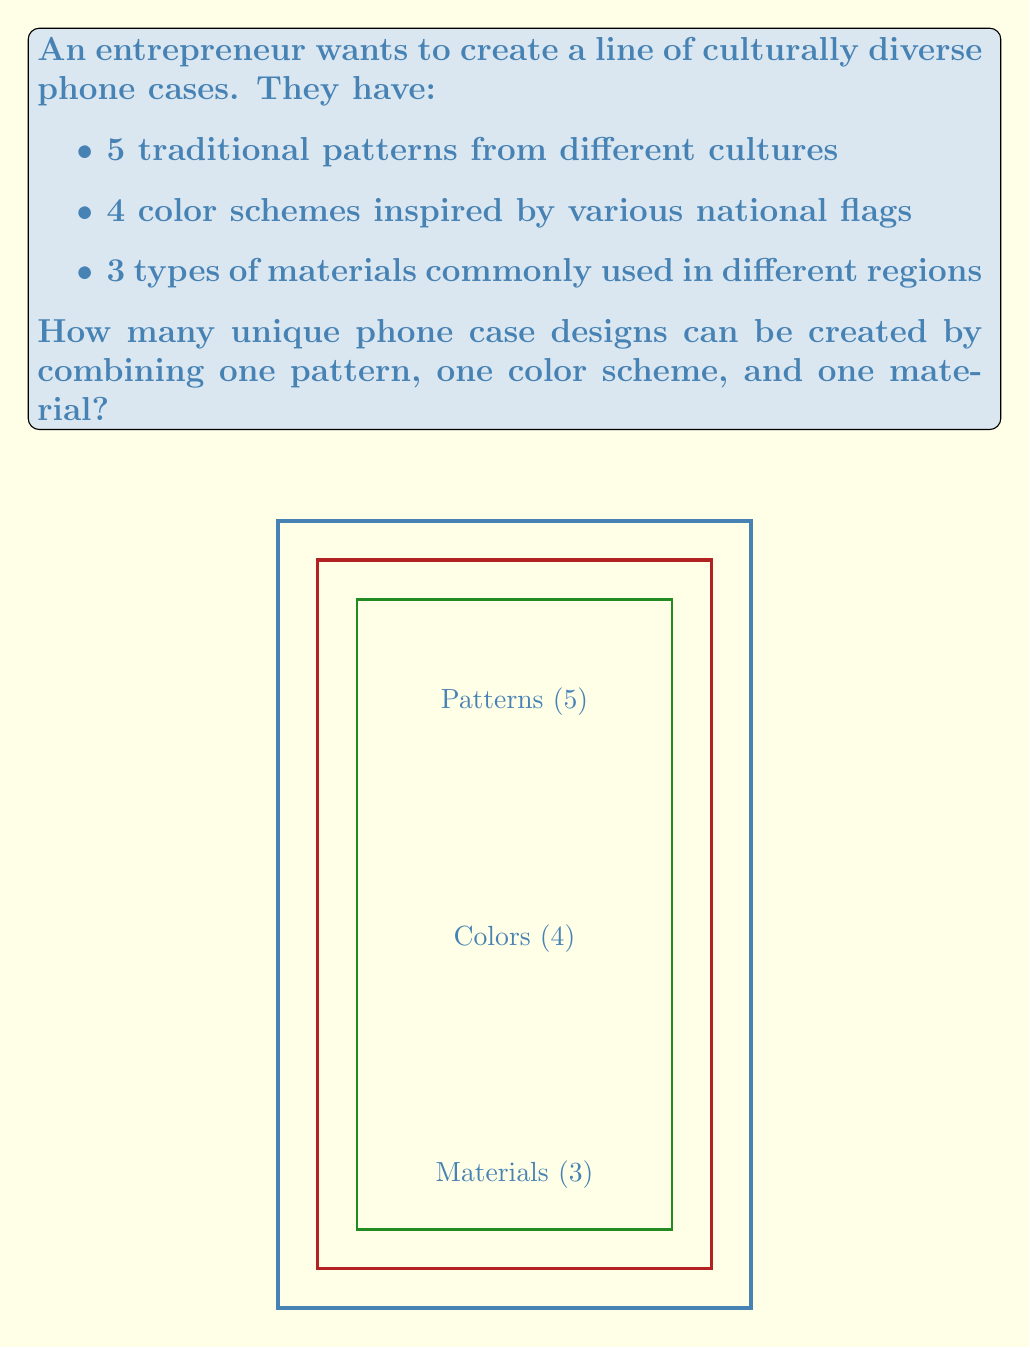Can you answer this question? To solve this problem, we can use the multiplication principle of combinatorics. The multiplication principle states that if we have $m$ ways of doing something and $n$ ways of doing another thing, then there are $m \times n$ ways of doing both things.

In this case, we have:
1. 5 traditional patterns
2. 4 color schemes
3. 3 types of materials

For each phone case, we need to choose:
- One pattern out of 5 options
- One color scheme out of 4 options
- One material out of 3 options

Therefore, the total number of unique combinations is:

$$ \text{Total combinations} = 5 \times 4 \times 3 $$

Calculating this:
$$ 5 \times 4 \times 3 = 20 \times 3 = 60 $$

Thus, the entrepreneur can create 60 unique phone case designs by combining one pattern, one color scheme, and one material.
Answer: 60 